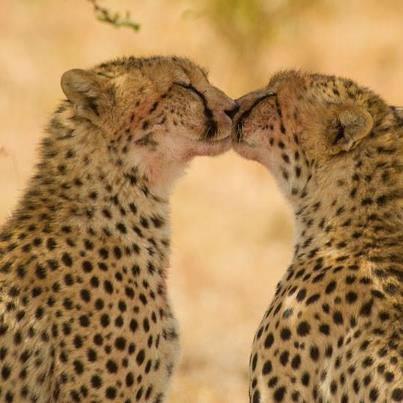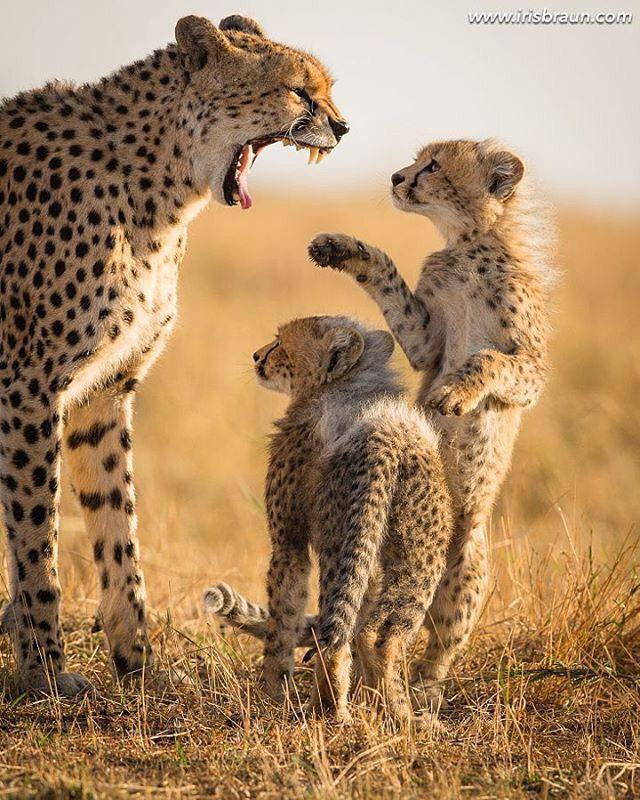The first image is the image on the left, the second image is the image on the right. For the images displayed, is the sentence "One image contains two cheetah kittens and one adult cheetah, and one of the kittens is standing on its hind legs so its head is nearly even with the upright adult cat." factually correct? Answer yes or no. Yes. The first image is the image on the left, the second image is the image on the right. Evaluate the accuracy of this statement regarding the images: "One image shows only adult cheetahs and the other shows one adult cheetah with two young cheetahs.". Is it true? Answer yes or no. Yes. 